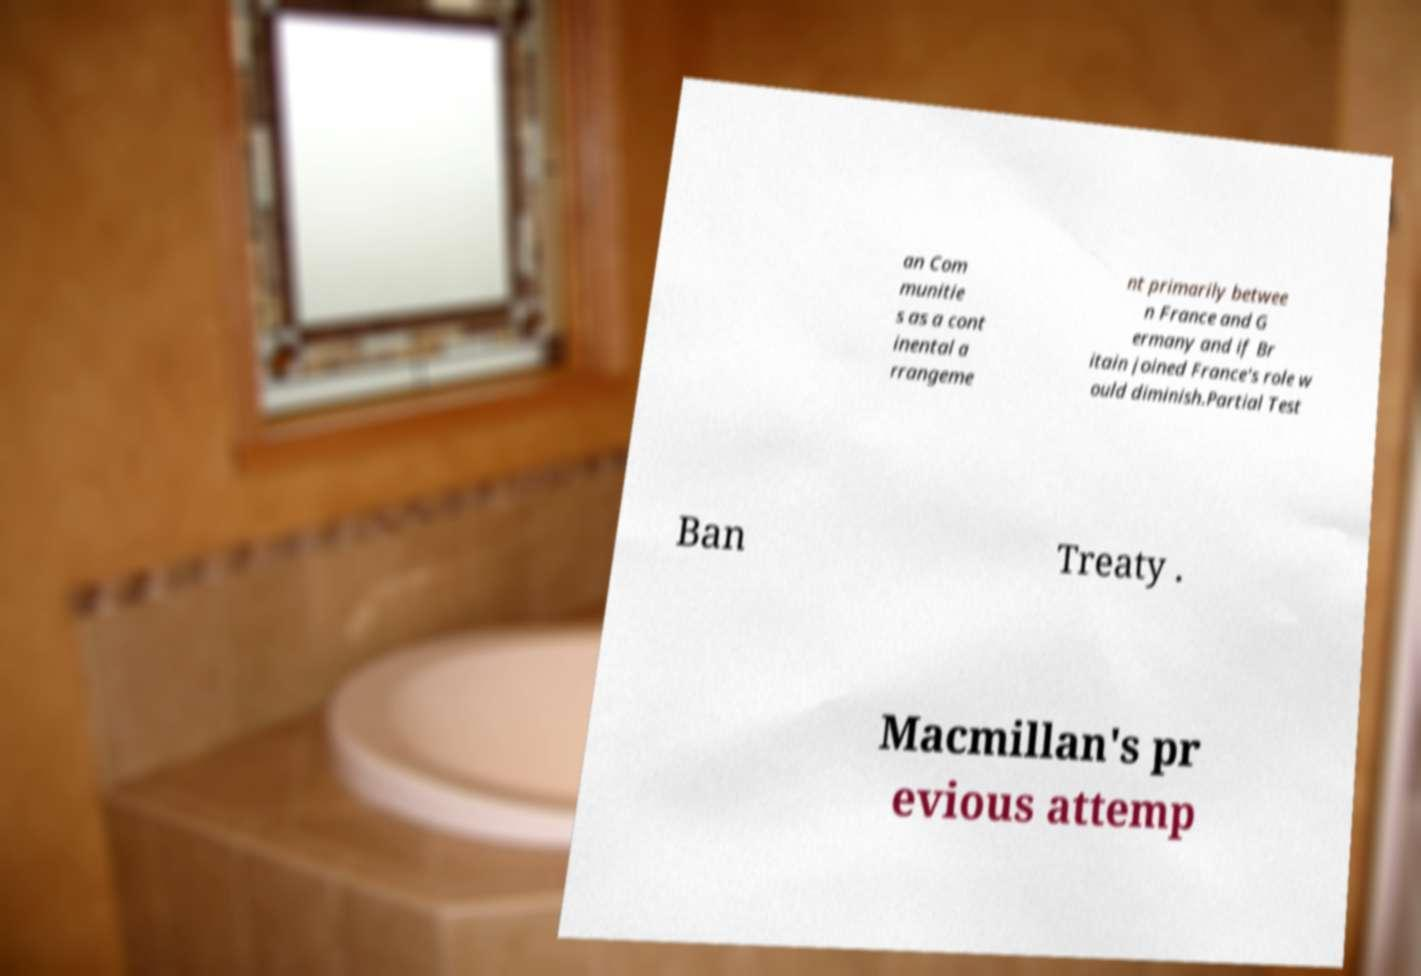Please identify and transcribe the text found in this image. an Com munitie s as a cont inental a rrangeme nt primarily betwee n France and G ermany and if Br itain joined France's role w ould diminish.Partial Test Ban Treaty . Macmillan's pr evious attemp 